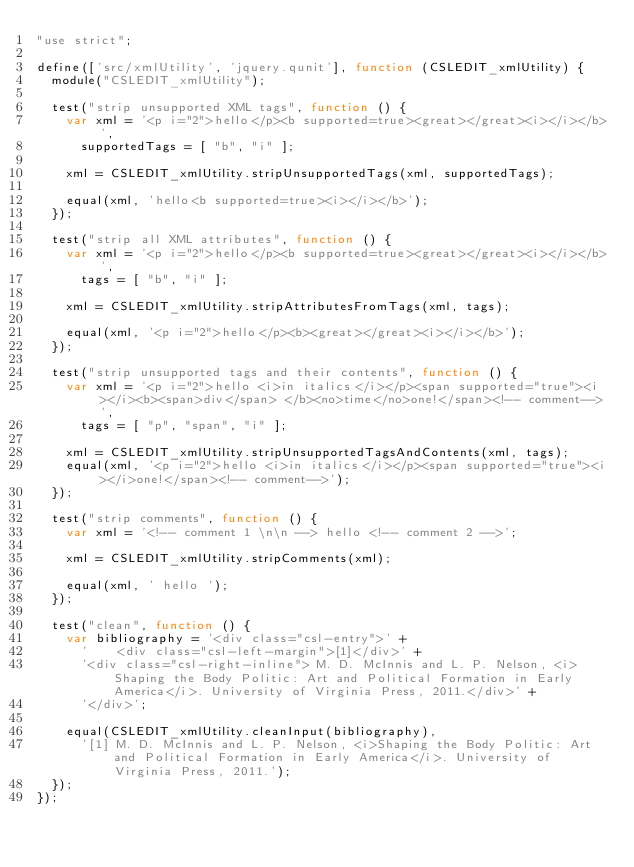Convert code to text. <code><loc_0><loc_0><loc_500><loc_500><_JavaScript_>"use strict";

define(['src/xmlUtility', 'jquery.qunit'], function (CSLEDIT_xmlUtility) {
	module("CSLEDIT_xmlUtility");

	test("strip unsupported XML tags", function () {
		var xml = '<p i="2">hello</p><b supported=true><great></great><i></i></b>',
			supportedTags = [ "b", "i" ];

		xml = CSLEDIT_xmlUtility.stripUnsupportedTags(xml, supportedTags);

		equal(xml, 'hello<b supported=true><i></i></b>');
	});

	test("strip all XML attributes", function () {
		var xml = '<p i="2">hello</p><b supported=true><great></great><i></i></b>',
			tags = [ "b", "i" ];

		xml = CSLEDIT_xmlUtility.stripAttributesFromTags(xml, tags);

		equal(xml, '<p i="2">hello</p><b><great></great><i></i></b>');
	});

	test("strip unsupported tags and their contents", function () {
		var xml = '<p i="2">hello <i>in italics</i></p><span supported="true"><i></i><b><span>div</span> </b><no>time</no>one!</span><!-- comment-->',
			tags = [ "p", "span", "i" ];

		xml = CSLEDIT_xmlUtility.stripUnsupportedTagsAndContents(xml, tags);
		equal(xml, '<p i="2">hello <i>in italics</i></p><span supported="true"><i></i>one!</span><!-- comment-->');
	});

	test("strip comments", function () {
		var xml = '<!-- comment 1 \n\n --> hello <!-- comment 2 -->';

		xml = CSLEDIT_xmlUtility.stripComments(xml);

		equal(xml, ' hello ');
	});

	test("clean", function () {
		var bibliography = '<div class="csl-entry">' +
			'    <div class="csl-left-margin">[1]</div>' +
			'<div class="csl-right-inline"> M. D. McInnis and L. P. Nelson, <i>Shaping the Body Politic: Art and Political Formation in Early America</i>. University of Virginia Press, 2011.</div>' +
			'</div>';

		equal(CSLEDIT_xmlUtility.cleanInput(bibliography),
			'[1] M. D. McInnis and L. P. Nelson, <i>Shaping the Body Politic: Art and Political Formation in Early America</i>. University of Virginia Press, 2011.');
	});
});
</code> 